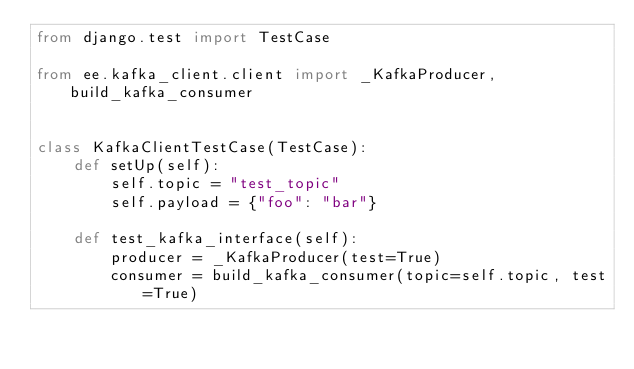Convert code to text. <code><loc_0><loc_0><loc_500><loc_500><_Python_>from django.test import TestCase

from ee.kafka_client.client import _KafkaProducer, build_kafka_consumer


class KafkaClientTestCase(TestCase):
    def setUp(self):
        self.topic = "test_topic"
        self.payload = {"foo": "bar"}

    def test_kafka_interface(self):
        producer = _KafkaProducer(test=True)
        consumer = build_kafka_consumer(topic=self.topic, test=True)
</code> 